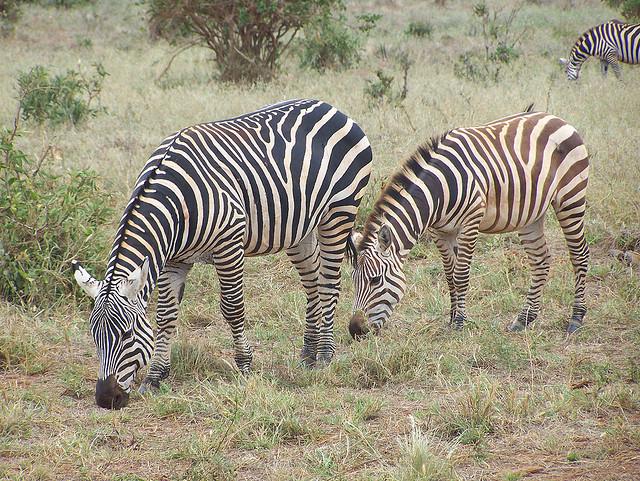Where do the zebras live?
Short answer required. Savannah. What is the only brown object in the photo?
Answer briefly. Tree. Is the zebra likely to be pregnant?
Keep it brief. No. Are the zebras running?
Answer briefly. No. What continent is the animal found on?
Answer briefly. Africa. How many zebras are in this picture?
Concise answer only. 3. 